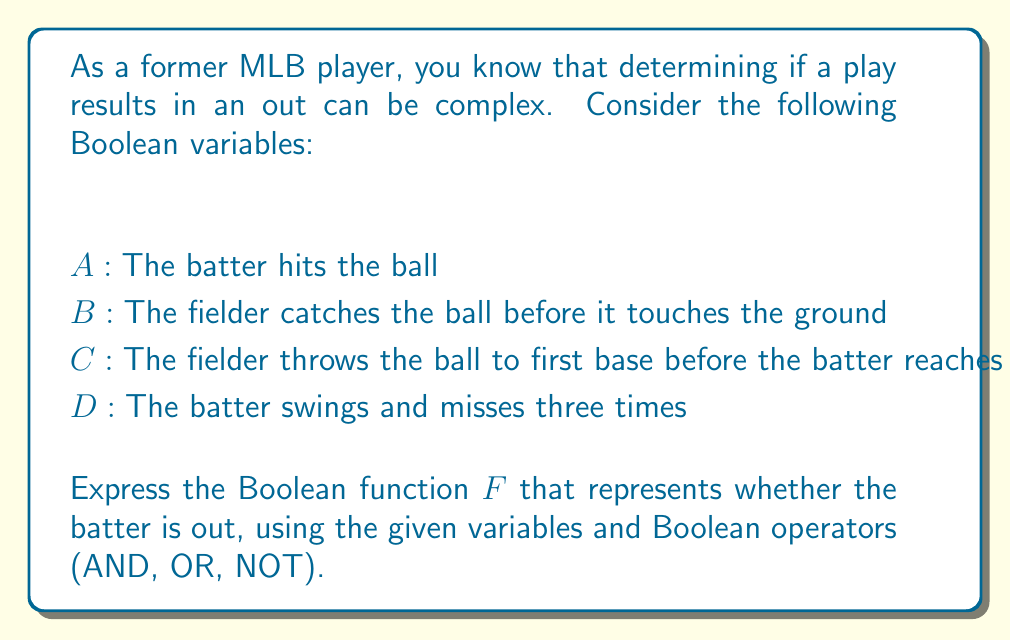Give your solution to this math problem. Let's break this down step-by-step:

1) There are three ways a batter can be out in this scenario:
   a) The batter hits the ball and it's caught before touching the ground (fly out).
   b) The batter hits the ball, it's not caught, but thrown to first base before the batter reaches (ground out).
   c) The batter strikes out by swinging and missing three times.

2) Let's express each of these scenarios using Boolean algebra:
   a) Fly out: $A \land B$
   b) Ground out: $A \land \lnot B \land C$
   c) Strike out: $D$

3) The batter is out if any of these scenarios occur. In Boolean algebra, "or" is represented by the $\lor$ operator.

4) Therefore, the complete Boolean function is:
   $$F = (A \land B) \lor (A \land \lnot B \land C) \lor D$$

5) This can be simplified slightly using the distributive property:
   $$F = A(B \lor (\lnot B \land C)) \lor D$$

This Boolean function $F$ will evaluate to true (1) if the batter is out, and false (0) if the batter is not out.
Answer: $F = A(B \lor (\lnot B \land C)) \lor D$ 